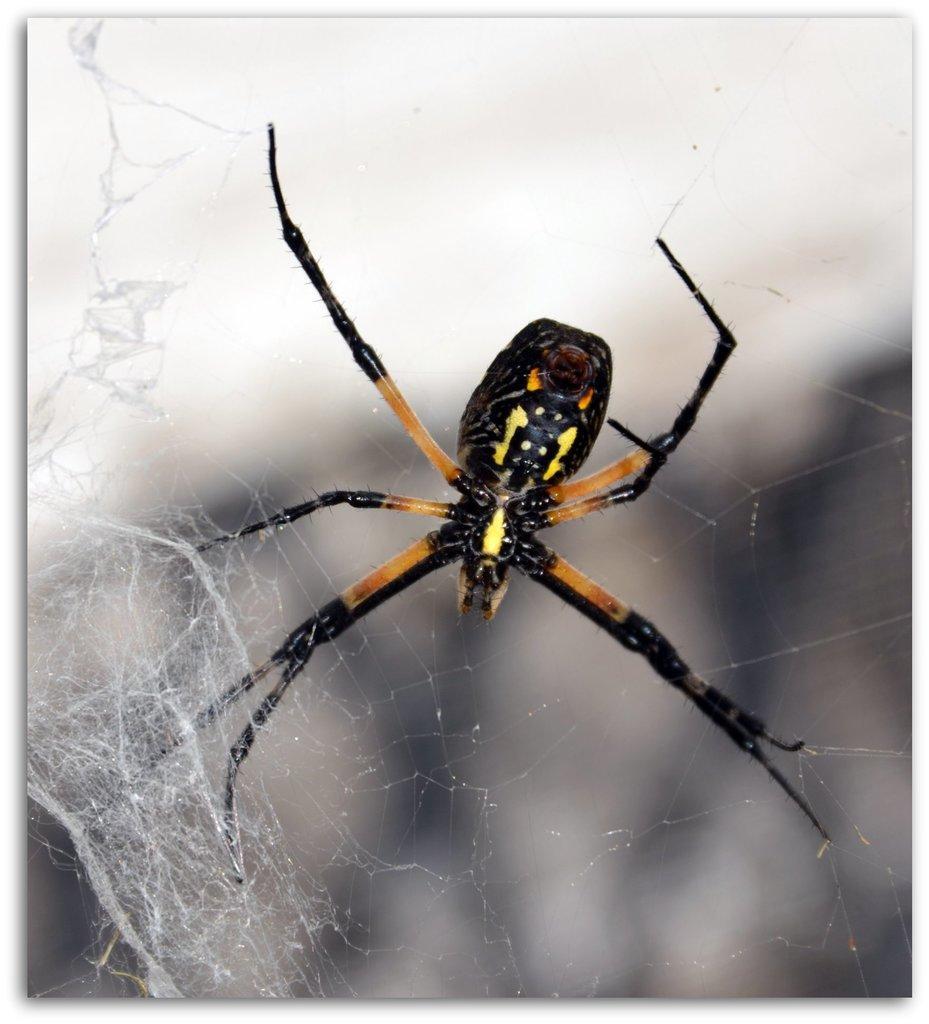In one or two sentences, can you explain what this image depicts? In this picture I can see there is a spider and it has legs and body, there is a web around it and the backdrop is blurred. 